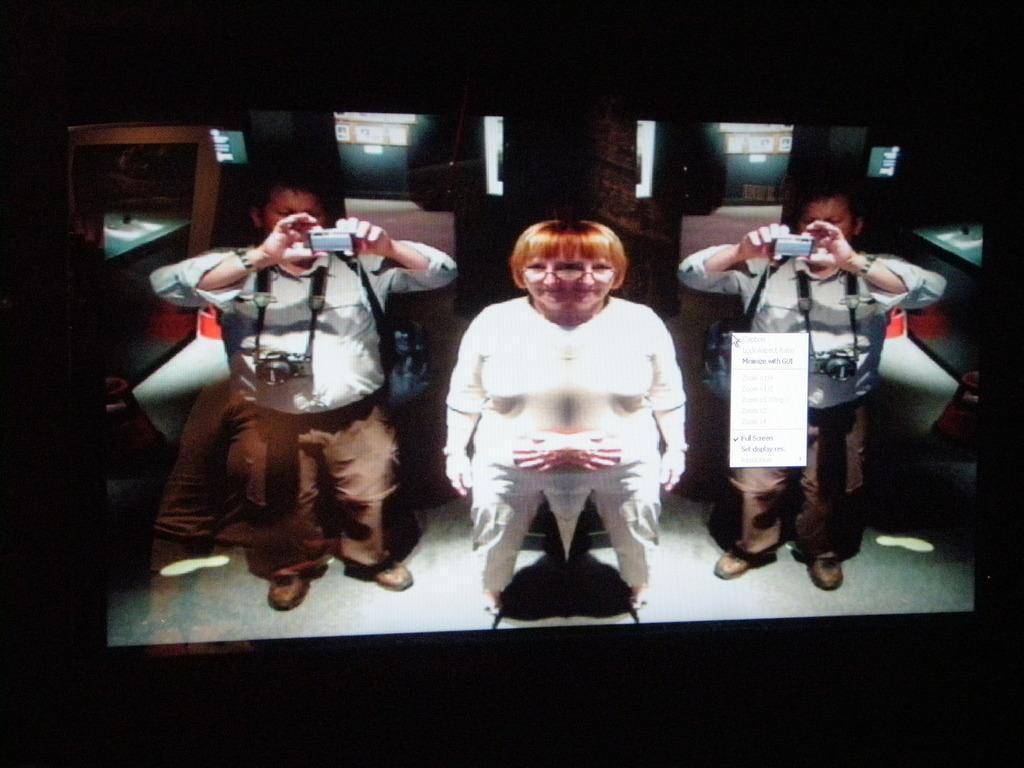How would you summarize this image in a sentence or two? In this picture there is a women wearing white color dress standing and giving a pose into the camera. Beside there is a man who is taking a photograph. In the background we can see the glass. 